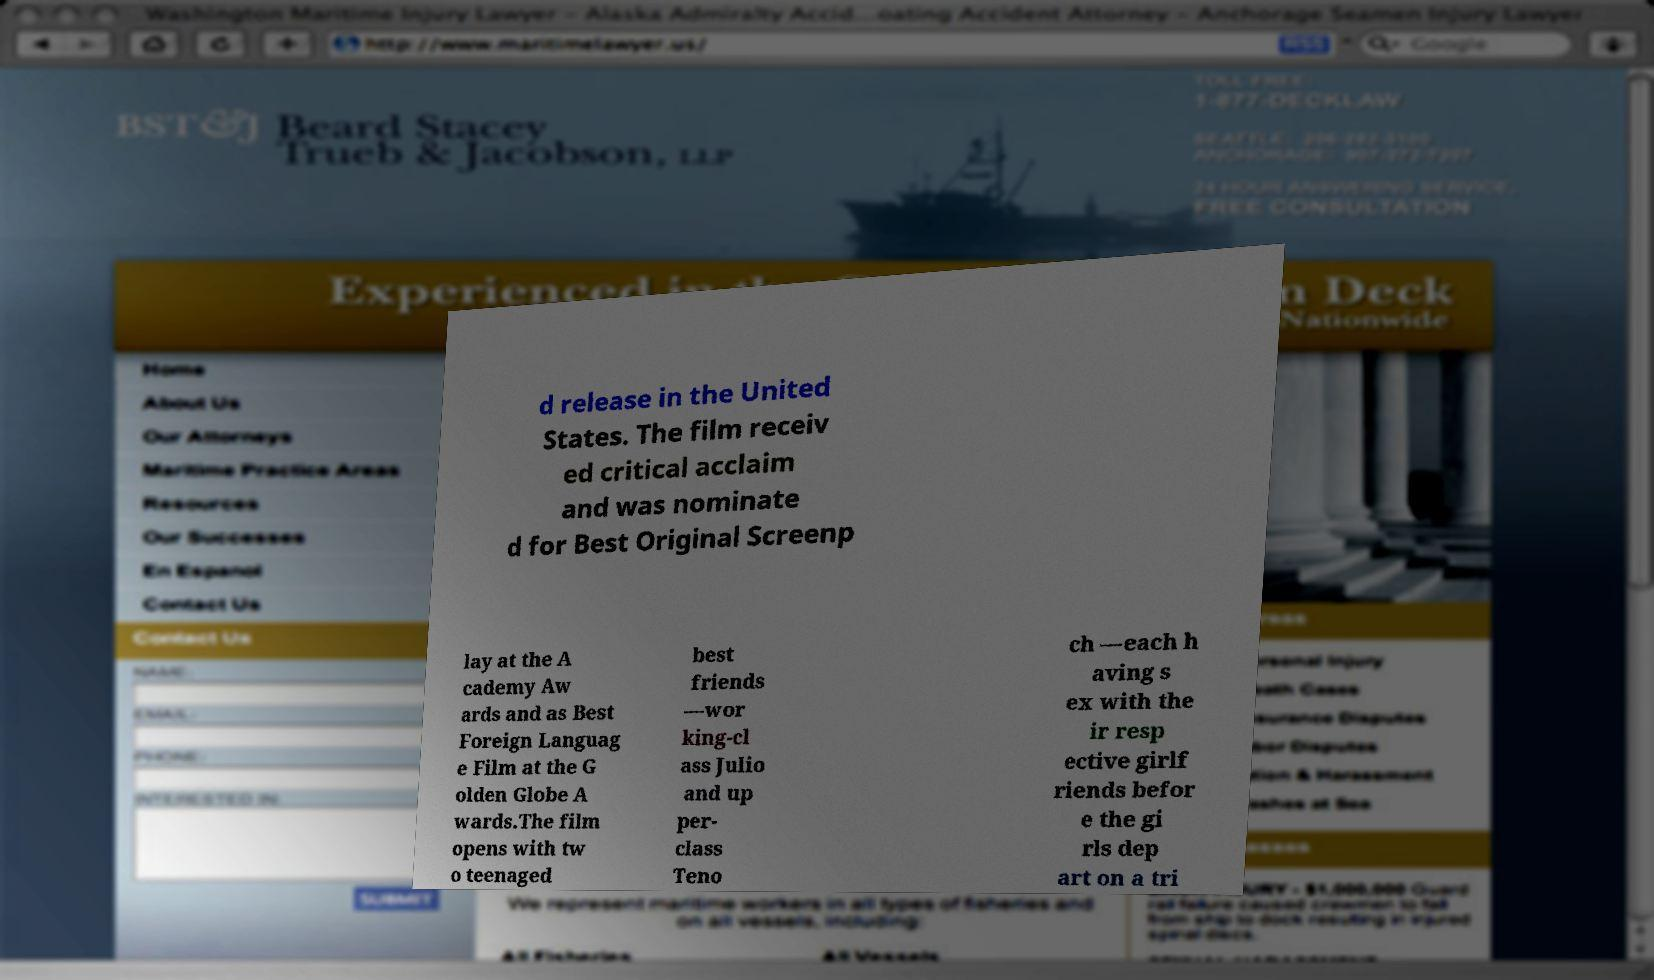Can you accurately transcribe the text from the provided image for me? d release in the United States. The film receiv ed critical acclaim and was nominate d for Best Original Screenp lay at the A cademy Aw ards and as Best Foreign Languag e Film at the G olden Globe A wards.The film opens with tw o teenaged best friends —wor king-cl ass Julio and up per- class Teno ch —each h aving s ex with the ir resp ective girlf riends befor e the gi rls dep art on a tri 